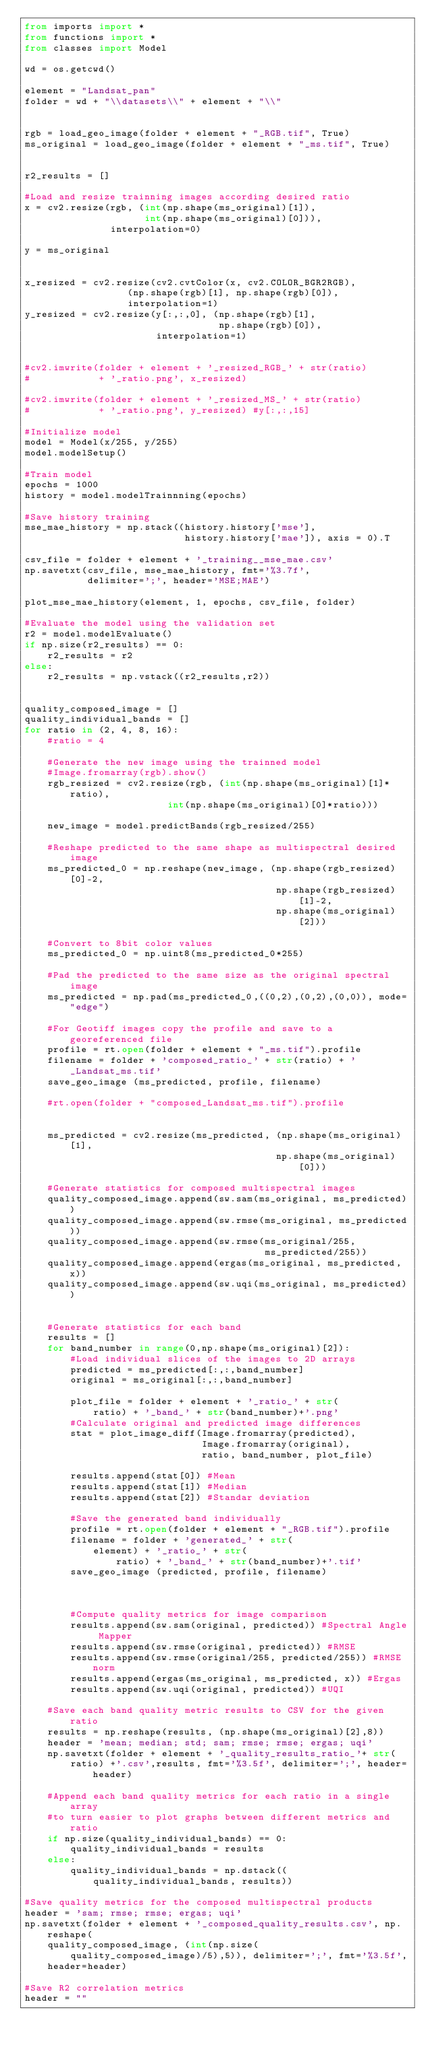Convert code to text. <code><loc_0><loc_0><loc_500><loc_500><_Python_>from imports import *
from functions import *
from classes import Model

wd = os.getcwd()

element = "Landsat_pan"
folder = wd + "\\datasets\\" + element + "\\"


rgb = load_geo_image(folder + element + "_RGB.tif", True)
ms_original = load_geo_image(folder + element + "_ms.tif", True)


r2_results = []
    
#Load and resize trainning images according desired ratio
x = cv2.resize(rgb, (int(np.shape(ms_original)[1]),
                     int(np.shape(ms_original)[0])),
               interpolation=0)

y = ms_original


x_resized = cv2.resize(cv2.cvtColor(x, cv2.COLOR_BGR2RGB), 
                  (np.shape(rgb)[1], np.shape(rgb)[0]), 
                  interpolation=1)
y_resized = cv2.resize(y[:,:,0], (np.shape(rgb)[1],
                                  np.shape(rgb)[0]),
                       interpolation=1)


#cv2.imwrite(folder + element + '_resized_RGB_' + str(ratio) 
#            + '_ratio.png', x_resized)

#cv2.imwrite(folder + element + '_resized_MS_' + str(ratio) 
#            + '_ratio.png', y_resized) #y[:,:,15]

#Initialize model
model = Model(x/255, y/255)        
model.modelSetup()

#Train model
epochs = 1000
history = model.modelTrainnning(epochs)

#Save history training
mse_mae_history = np.stack((history.history['mse'],
                            history.history['mae']), axis = 0).T

csv_file = folder + element + '_training__mse_mae.csv'
np.savetxt(csv_file, mse_mae_history, fmt='%3.7f', 
           delimiter=';', header='MSE;MAE')

plot_mse_mae_history(element, 1, epochs, csv_file, folder)

#Evaluate the model using the validation set
r2 = model.modelEvaluate()
if np.size(r2_results) == 0:
    r2_results = r2
else:
    r2_results = np.vstack((r2_results,r2))
        
    
quality_composed_image = []
quality_individual_bands = []
for ratio in (2, 4, 8, 16):
    #ratio = 4
    
    #Generate the new image using the trainned model
    #Image.fromarray(rgb).show()
    rgb_resized = cv2.resize(rgb, (int(np.shape(ms_original)[1]*ratio),
                         int(np.shape(ms_original)[0]*ratio)))        
        
    new_image = model.predictBands(rgb_resized/255)
    
    #Reshape predicted to the same shape as multispectral desired image
    ms_predicted_0 = np.reshape(new_image, (np.shape(rgb_resized)[0]-2, 
                                            np.shape(rgb_resized)[1]-2, 
                                            np.shape(ms_original)[2]))
    
    #Convert to 8bit color values
    ms_predicted_0 = np.uint8(ms_predicted_0*255)
    
    #Pad the predicted to the same size as the original spectral image  
    ms_predicted = np.pad(ms_predicted_0,((0,2),(0,2),(0,0)), mode="edge")
    
    #For Geotiff images copy the profile and save to a georeferenced file
    profile = rt.open(folder + element + "_ms.tif").profile
    filename = folder + 'composed_ratio_' + str(ratio) + '_Landsat_ms.tif'
    save_geo_image (ms_predicted, profile, filename)
    
    #rt.open(folder + "composed_Landsat_ms.tif").profile
        
    
    ms_predicted = cv2.resize(ms_predicted, (np.shape(ms_original)[1], 
                                            np.shape(ms_original)[0]))
    
    #Generate statistics for composed multispectral images
    quality_composed_image.append(sw.sam(ms_original, ms_predicted))
    quality_composed_image.append(sw.rmse(ms_original, ms_predicted))
    quality_composed_image.append(sw.rmse(ms_original/255,
                                          ms_predicted/255))
    quality_composed_image.append(ergas(ms_original, ms_predicted, x))
    quality_composed_image.append(sw.uqi(ms_original, ms_predicted))


    #Generate statistics for each band
    results = []
    for band_number in range(0,np.shape(ms_original)[2]):
        #Load individual slices of the images to 2D arrays
        predicted = ms_predicted[:,:,band_number]
        original = ms_original[:,:,band_number]
        
        plot_file = folder + element + '_ratio_' + str(
            ratio) + '_band_' + str(band_number)+'.png'
        #Calculate original and predicted image differences
        stat = plot_image_diff(Image.fromarray(predicted),
                               Image.fromarray(original),
                               ratio, band_number, plot_file)
        
        results.append(stat[0]) #Mean
        results.append(stat[1]) #Median
        results.append(stat[2]) #Standar deviation
            
        #Save the generated band individually
        profile = rt.open(folder + element + "_RGB.tif").profile
        filename = folder + 'generated_' + str(
            element) + '_ratio_' + str(
                ratio) + '_band_' + str(band_number)+'.tif'
        save_geo_image (predicted, profile, filename)               



        #Compute quality metrics for image comparison
        results.append(sw.sam(original, predicted)) #Spectral Angle Mapper
        results.append(sw.rmse(original, predicted)) #RMSE
        results.append(sw.rmse(original/255, predicted/255)) #RMSE norm
        results.append(ergas(ms_original, ms_predicted, x)) #Ergas
        results.append(sw.uqi(original, predicted)) #UQI
    
    #Save each band quality metric results to CSV for the given ratio
    results = np.reshape(results, (np.shape(ms_original)[2],8))
    header = 'mean; median; std; sam; rmse; rmse; ergas; uqi'
    np.savetxt(folder + element + '_quality_results_ratio_'+ str(
        ratio) +'.csv',results, fmt='%3.5f', delimiter=';', header=header)
    
    #Append each band quality metrics for each ratio in a single array
    #to turn easier to plot graphs between different metrics and ratio
    if np.size(quality_individual_bands) == 0:
        quality_individual_bands = results
    else:
        quality_individual_bands = np.dstack((
            quality_individual_bands, results))
        
#Save quality metrics for the composed multispectral products
header = 'sam; rmse; rmse; ergas; uqi'
np.savetxt(folder + element + '_composed_quality_results.csv', np.reshape(
    quality_composed_image, (int(np.size(
        quality_composed_image)/5),5)), delimiter=';', fmt='%3.5f',
    header=header)         
        
#Save R2 correlation metrics
header = ""</code> 